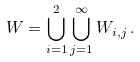<formula> <loc_0><loc_0><loc_500><loc_500>W = \bigcup _ { i = 1 } ^ { 2 } \bigcup _ { j = 1 } ^ { \infty } W _ { i , j } \, .</formula> 